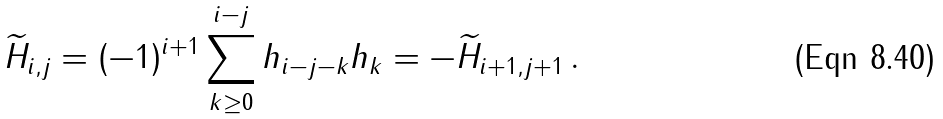Convert formula to latex. <formula><loc_0><loc_0><loc_500><loc_500>\widetilde { H } _ { i , j } = ( - 1 ) ^ { i + 1 } \sum _ { k \geq 0 } ^ { i - j } h _ { i - j - k } h _ { k } = - \widetilde { H } _ { i + 1 , j + 1 } \, .</formula> 